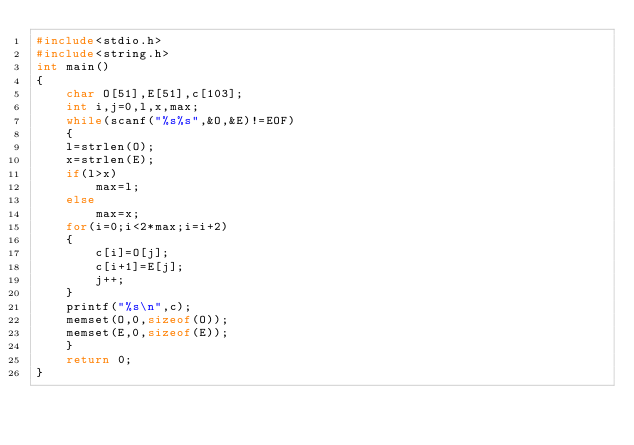<code> <loc_0><loc_0><loc_500><loc_500><_C_>#include<stdio.h>
#include<string.h>
int main()
{
    char O[51],E[51],c[103];
    int i,j=0,l,x,max;
    while(scanf("%s%s",&O,&E)!=EOF)
    {
    l=strlen(O);
    x=strlen(E);
    if(l>x)
        max=l;
    else
        max=x;
    for(i=0;i<2*max;i=i+2)
    {
        c[i]=O[j];
        c[i+1]=E[j];
        j++;
    }
    printf("%s\n",c);
    memset(O,0,sizeof(O));
    memset(E,0,sizeof(E));
    }
    return 0;
}</code> 